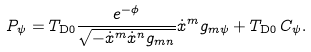Convert formula to latex. <formula><loc_0><loc_0><loc_500><loc_500>P _ { \psi } = T _ { \text {D} 0 } \frac { e ^ { - \phi } } { \sqrt { - \dot { x } ^ { m } \dot { x } ^ { n } g _ { m n } } } \dot { x } ^ { m } g _ { m \psi } + T _ { \text {D} 0 } \, C _ { \psi } .</formula> 